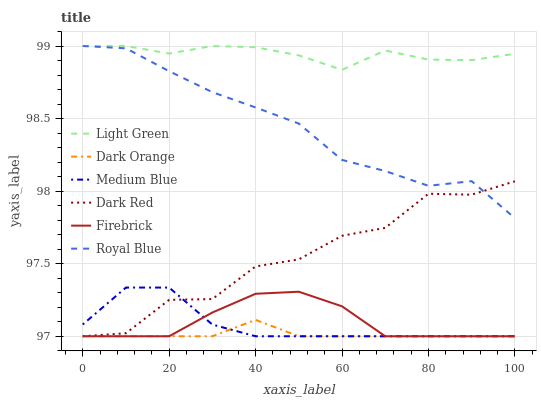Does Dark Orange have the minimum area under the curve?
Answer yes or no. Yes. Does Light Green have the maximum area under the curve?
Answer yes or no. Yes. Does Dark Red have the minimum area under the curve?
Answer yes or no. No. Does Dark Red have the maximum area under the curve?
Answer yes or no. No. Is Dark Orange the smoothest?
Answer yes or no. Yes. Is Dark Red the roughest?
Answer yes or no. Yes. Is Firebrick the smoothest?
Answer yes or no. No. Is Firebrick the roughest?
Answer yes or no. No. Does Dark Orange have the lowest value?
Answer yes or no. Yes. Does Royal Blue have the lowest value?
Answer yes or no. No. Does Light Green have the highest value?
Answer yes or no. Yes. Does Dark Red have the highest value?
Answer yes or no. No. Is Firebrick less than Royal Blue?
Answer yes or no. Yes. Is Light Green greater than Firebrick?
Answer yes or no. Yes. Does Medium Blue intersect Dark Orange?
Answer yes or no. Yes. Is Medium Blue less than Dark Orange?
Answer yes or no. No. Is Medium Blue greater than Dark Orange?
Answer yes or no. No. Does Firebrick intersect Royal Blue?
Answer yes or no. No. 